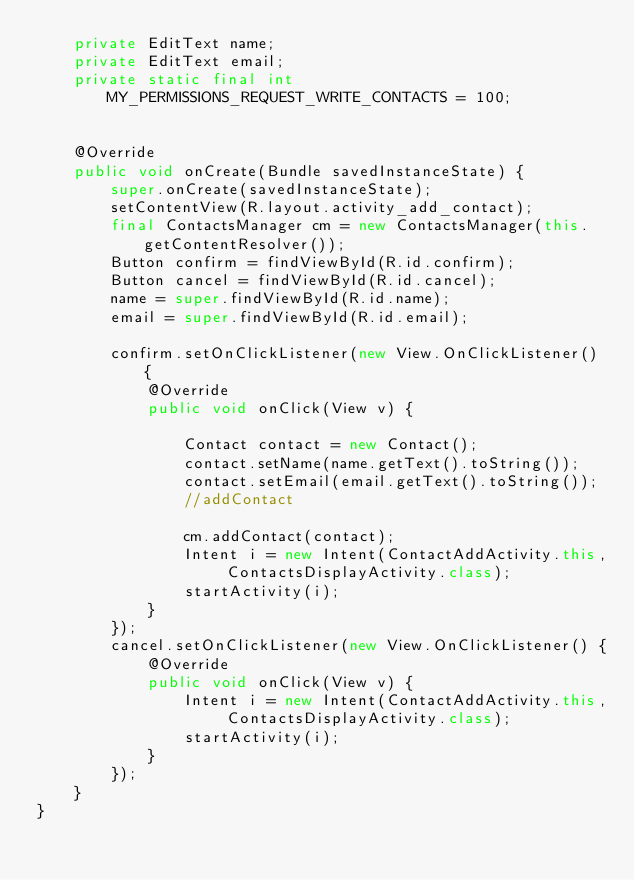Convert code to text. <code><loc_0><loc_0><loc_500><loc_500><_Java_>    private EditText name;
    private EditText email;
    private static final int MY_PERMISSIONS_REQUEST_WRITE_CONTACTS = 100;


    @Override
    public void onCreate(Bundle savedInstanceState) {
        super.onCreate(savedInstanceState);
        setContentView(R.layout.activity_add_contact);
        final ContactsManager cm = new ContactsManager(this.getContentResolver());
        Button confirm = findViewById(R.id.confirm);
        Button cancel = findViewById(R.id.cancel);
        name = super.findViewById(R.id.name);
        email = super.findViewById(R.id.email);

        confirm.setOnClickListener(new View.OnClickListener() {
            @Override
            public void onClick(View v) {

                Contact contact = new Contact();
                contact.setName(name.getText().toString());
                contact.setEmail(email.getText().toString());
                //addContact

                cm.addContact(contact);
                Intent i = new Intent(ContactAddActivity.this, ContactsDisplayActivity.class);
                startActivity(i);
            }
        });
        cancel.setOnClickListener(new View.OnClickListener() {
            @Override
            public void onClick(View v) {
                Intent i = new Intent(ContactAddActivity.this, ContactsDisplayActivity.class);
                startActivity(i);
            }
        });
    }
}
</code> 